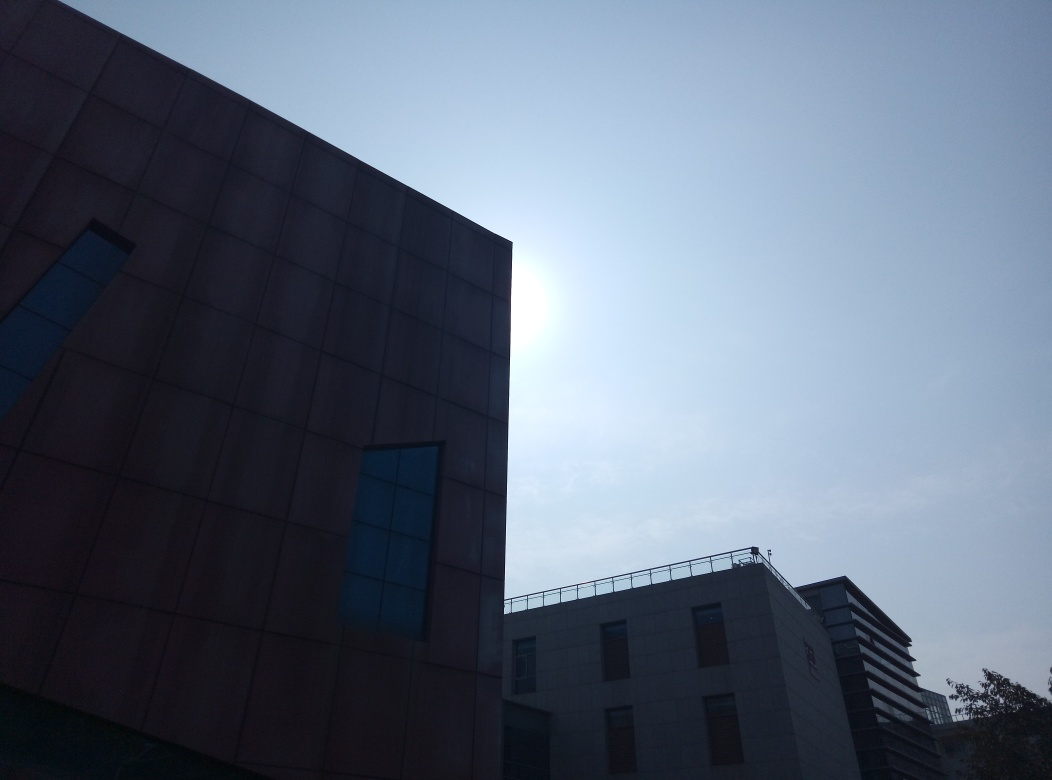What could be the function of the buildings shown? Without additional context, it is challenging to determine their exact function, but given their size and design, they could be office buildings or part of a university or corporate campus. 